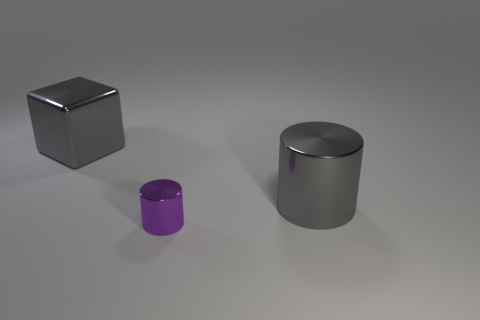Add 2 tiny purple matte cubes. How many objects exist? 5 Subtract all cylinders. How many objects are left? 1 Subtract all large gray metallic objects. Subtract all large metallic cylinders. How many objects are left? 0 Add 2 large shiny cylinders. How many large shiny cylinders are left? 3 Add 2 gray cylinders. How many gray cylinders exist? 3 Subtract 0 cyan cylinders. How many objects are left? 3 